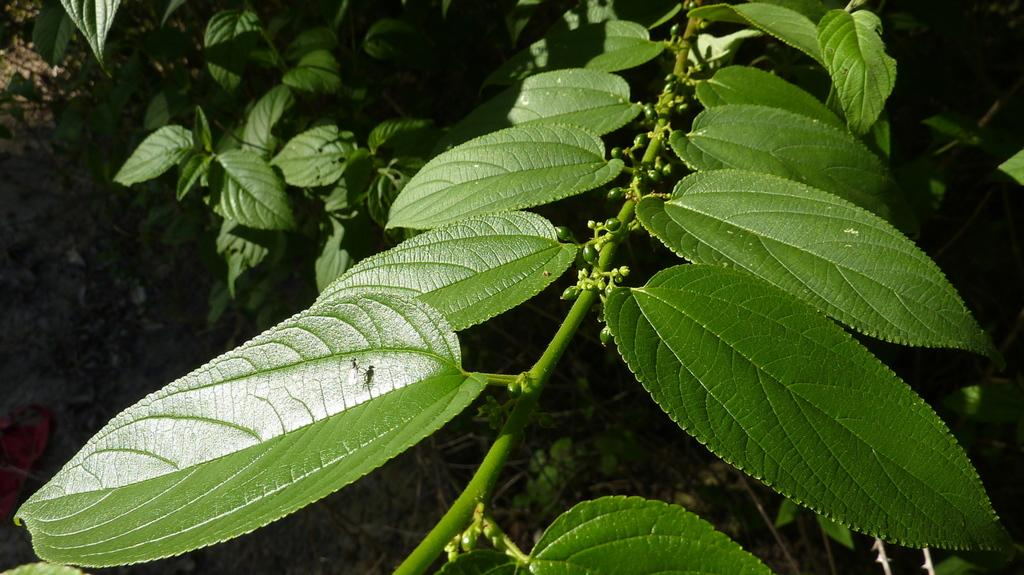What type of vegetation can be seen in the image? There are green leaves in the image. Can you describe the structure that connects the leaves? A: There is a stem in the image. How many trains can be seen in the image? There are no trains present in the image. What type of writer is depicted in the image? There is no writer depicted in the image. 